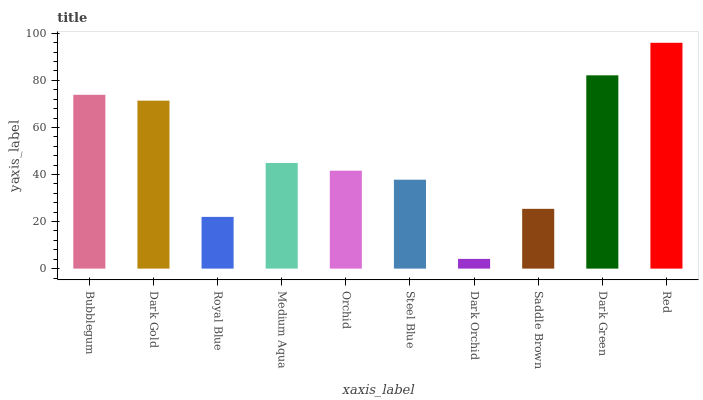Is Dark Orchid the minimum?
Answer yes or no. Yes. Is Red the maximum?
Answer yes or no. Yes. Is Dark Gold the minimum?
Answer yes or no. No. Is Dark Gold the maximum?
Answer yes or no. No. Is Bubblegum greater than Dark Gold?
Answer yes or no. Yes. Is Dark Gold less than Bubblegum?
Answer yes or no. Yes. Is Dark Gold greater than Bubblegum?
Answer yes or no. No. Is Bubblegum less than Dark Gold?
Answer yes or no. No. Is Medium Aqua the high median?
Answer yes or no. Yes. Is Orchid the low median?
Answer yes or no. Yes. Is Royal Blue the high median?
Answer yes or no. No. Is Dark Orchid the low median?
Answer yes or no. No. 